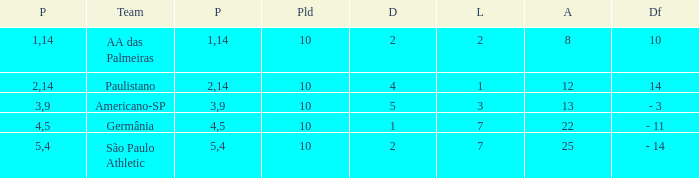What is the Against when the drawn is 5? 13.0. 